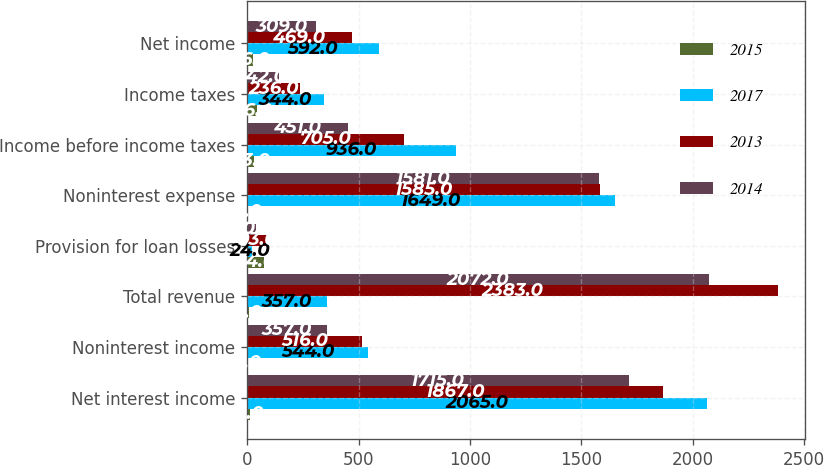<chart> <loc_0><loc_0><loc_500><loc_500><stacked_bar_chart><ecel><fcel>Net interest income<fcel>Noninterest income<fcel>Total revenue<fcel>Provision for loan losses<fcel>Noninterest expense<fcel>Income before income taxes<fcel>Income taxes<fcel>Net income<nl><fcel>2015<fcel>11<fcel>5<fcel>9<fcel>74<fcel>4<fcel>33<fcel>46<fcel>26<nl><fcel>2017<fcel>2065<fcel>544<fcel>357<fcel>24<fcel>1649<fcel>936<fcel>344<fcel>592<nl><fcel>2013<fcel>1867<fcel>516<fcel>2383<fcel>93<fcel>1585<fcel>705<fcel>236<fcel>469<nl><fcel>2014<fcel>1715<fcel>357<fcel>2072<fcel>40<fcel>1581<fcel>451<fcel>142<fcel>309<nl></chart> 